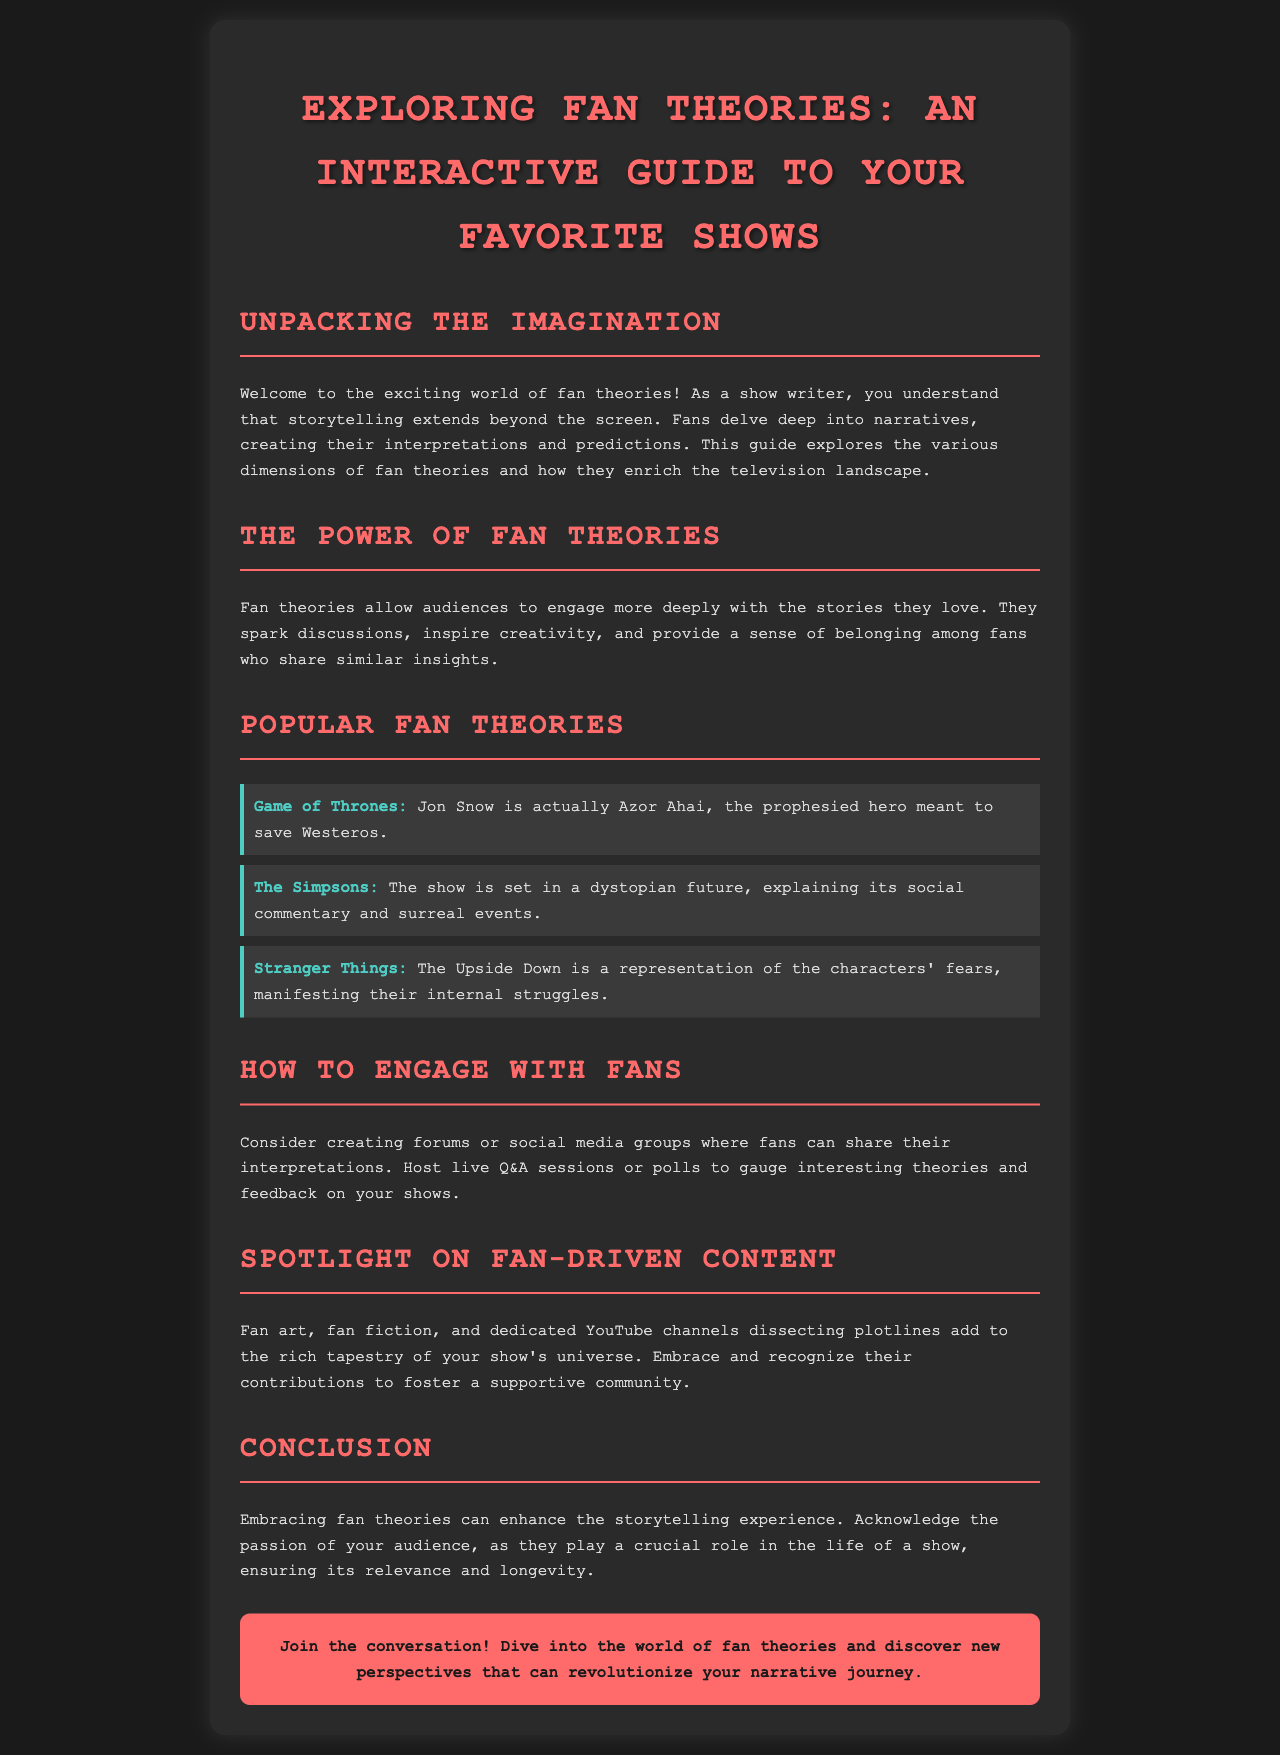What is the title of the brochure? The title is prominently displayed at the top of the document.
Answer: Exploring Fan Theories: An Interactive Guide to Your Favorite Shows What show is associated with the theory about Jon Snow? The theory specifically mentions a key character from a popular series.
Answer: Game of Thrones What is one way to engage with fans suggested in the document? The document provides various strategies to connect with the audience, including organizing specific events.
Answer: Host live Q&A sessions Which show's fan theory suggests that it is set in a dystopian future? This theory relates to a well-known animated series that often offers social commentary.
Answer: The Simpsons What is highlighted as a form of fan-driven content? The document lists various types of content created by fans that contribute to the show’s universe.
Answer: Fan art Why are fan theories important, according to the document? The document outlines the benefits that fan theories bring to the audience and community surrounding the show.
Answer: They spark discussions What color is used for the headings in the document? This detail can be gleaned from the style choices evident in the document layout.
Answer: #ff6b6b How many popular fan theories are presented in the document? The document provides a clear enumeration of the theories included.
Answer: Three 